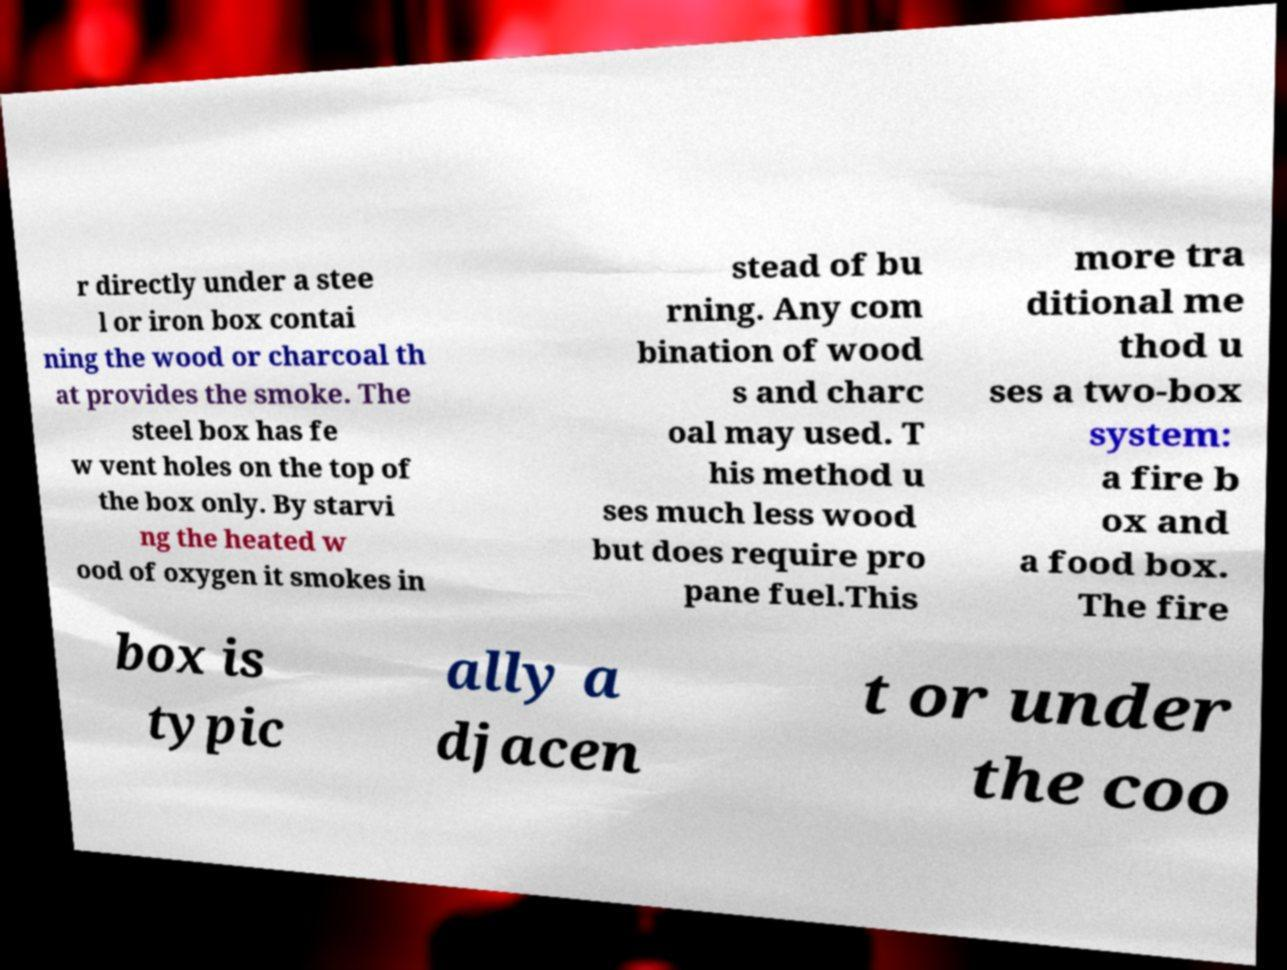Please identify and transcribe the text found in this image. r directly under a stee l or iron box contai ning the wood or charcoal th at provides the smoke. The steel box has fe w vent holes on the top of the box only. By starvi ng the heated w ood of oxygen it smokes in stead of bu rning. Any com bination of wood s and charc oal may used. T his method u ses much less wood but does require pro pane fuel.This more tra ditional me thod u ses a two-box system: a fire b ox and a food box. The fire box is typic ally a djacen t or under the coo 